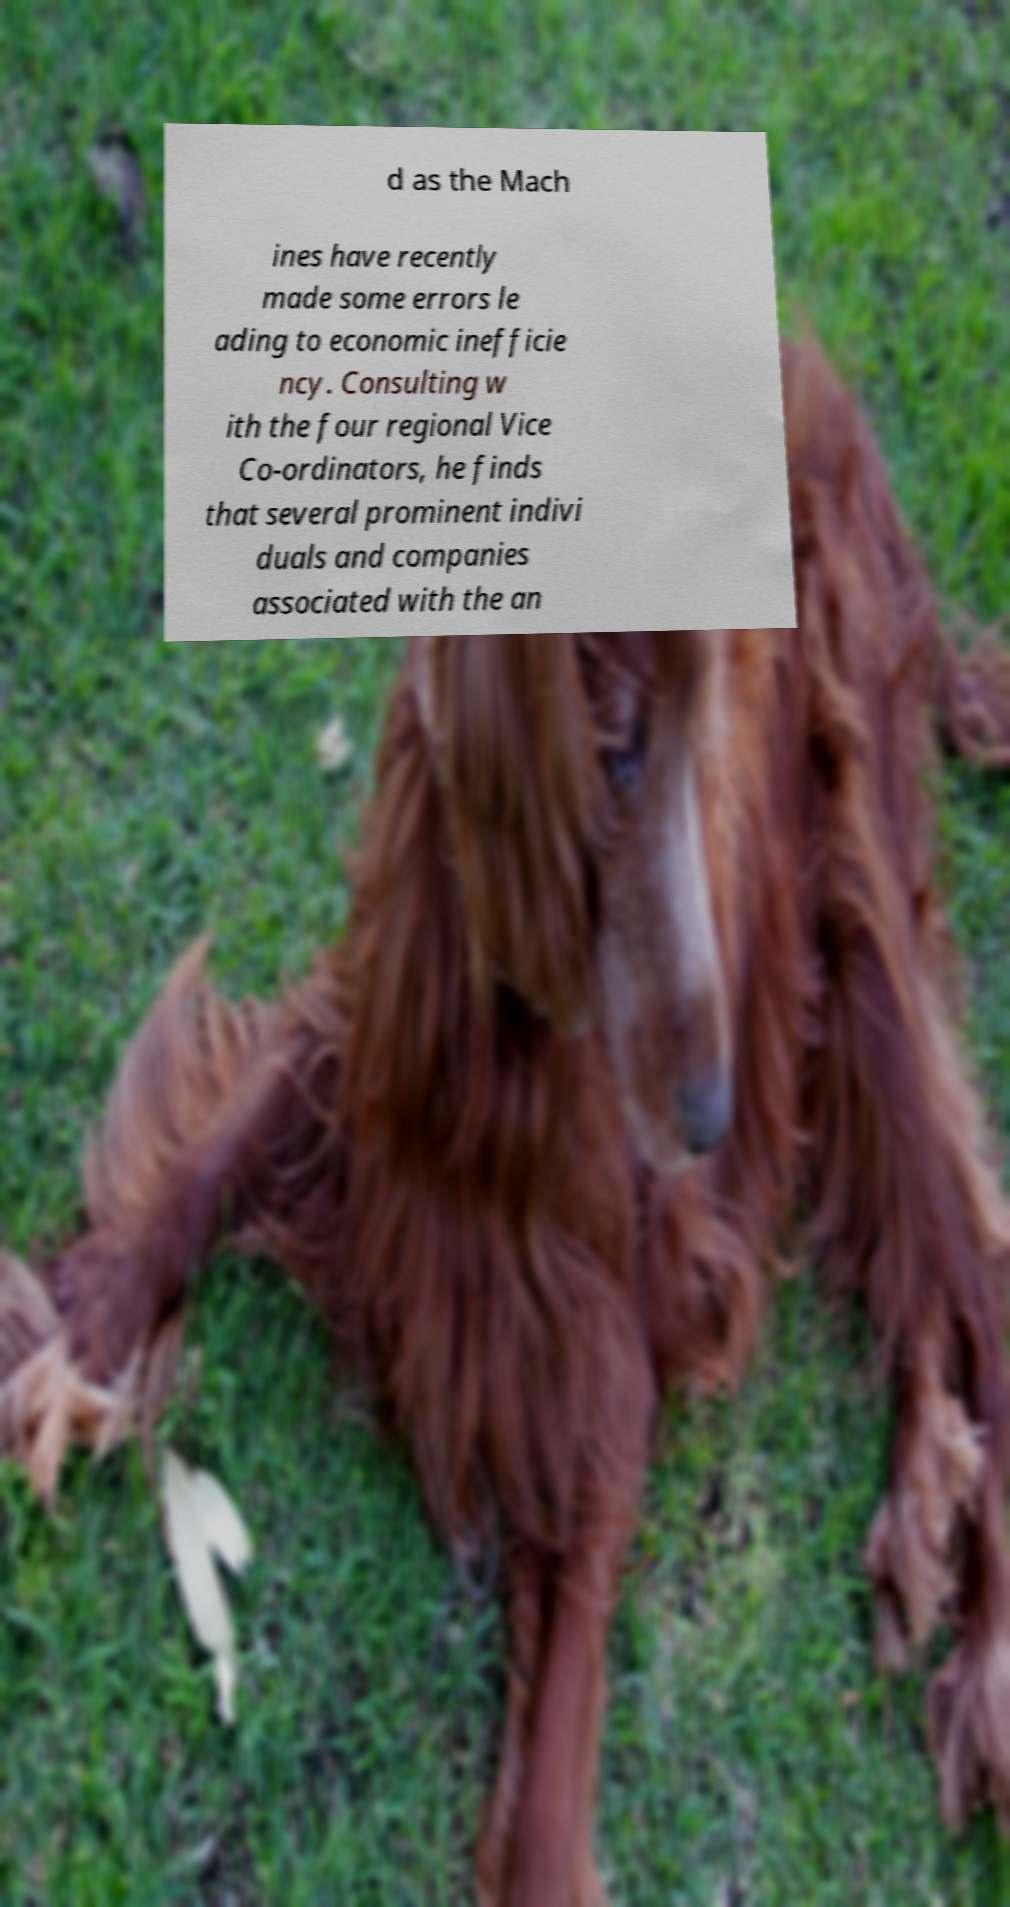Can you accurately transcribe the text from the provided image for me? d as the Mach ines have recently made some errors le ading to economic inefficie ncy. Consulting w ith the four regional Vice Co-ordinators, he finds that several prominent indivi duals and companies associated with the an 